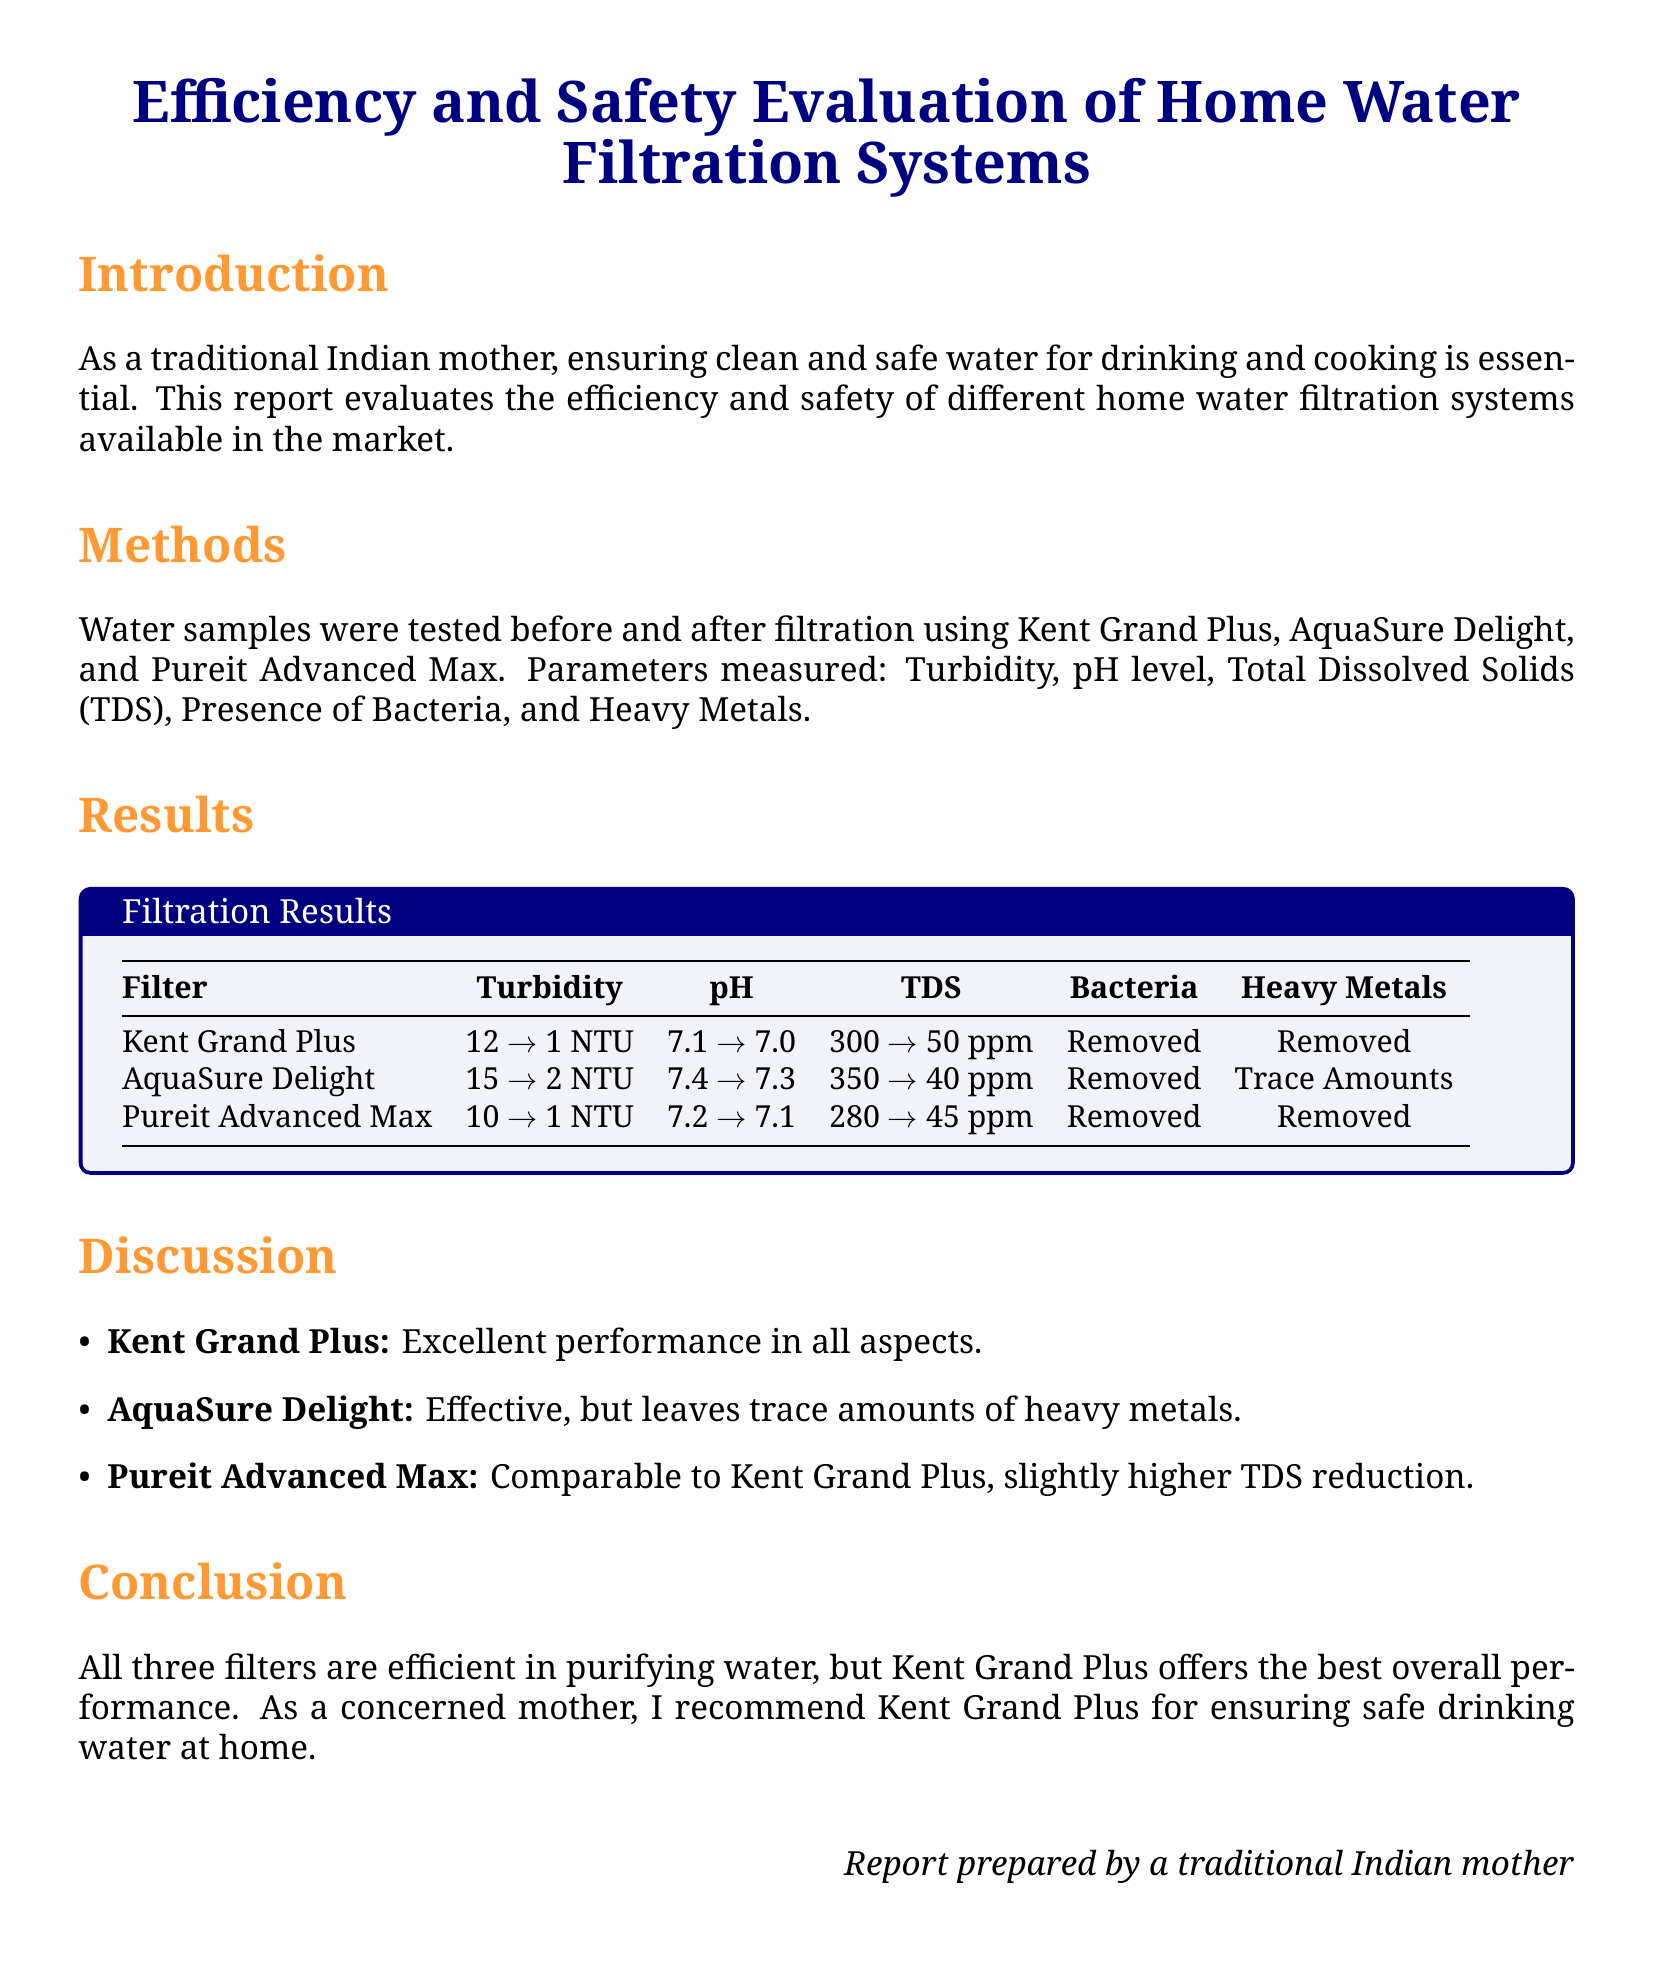What is the title of the report? The title of the report is the main heading presented at the top of the document.
Answer: Efficiency and Safety Evaluation of Home Water Filtration Systems Which filtration system had the best turbidity reduction? The results section provides specific values of turbidity before and after filtration.
Answer: Kent Grand Plus What was the pH level after filtration for AquaSure Delight? The report lists the pH levels before and after filtration for each system.
Answer: 7.3 What is the TDS reduction value for Pureit Advanced Max? The TDS values listed in the results demonstrate the before and after measurements for each filtration system.
Answer: 45 ppm Which filtration system removed bacteria completely? The results indicate the presence of bacteria before and after filtration across different systems.
Answer: All systems What does the discussion section say about AquaSure Delight? The discussion contains an evaluation of AquaSure Delight's effectiveness and performance in comparison to others.
Answer: Effective, but leaves trace amounts of heavy metals What is the main conclusion of the report? The conclusion summarizes the overall performance of the filtration systems evaluated.
Answer: Kent Grand Plus offers the best overall performance Which filter has the lowest starting turbidity? The results show starting turbidity levels for each filtration system.
Answer: Pureit Advanced Max Who prepared the report? The closing statement indicates the author of the report.
Answer: A traditional Indian mother 